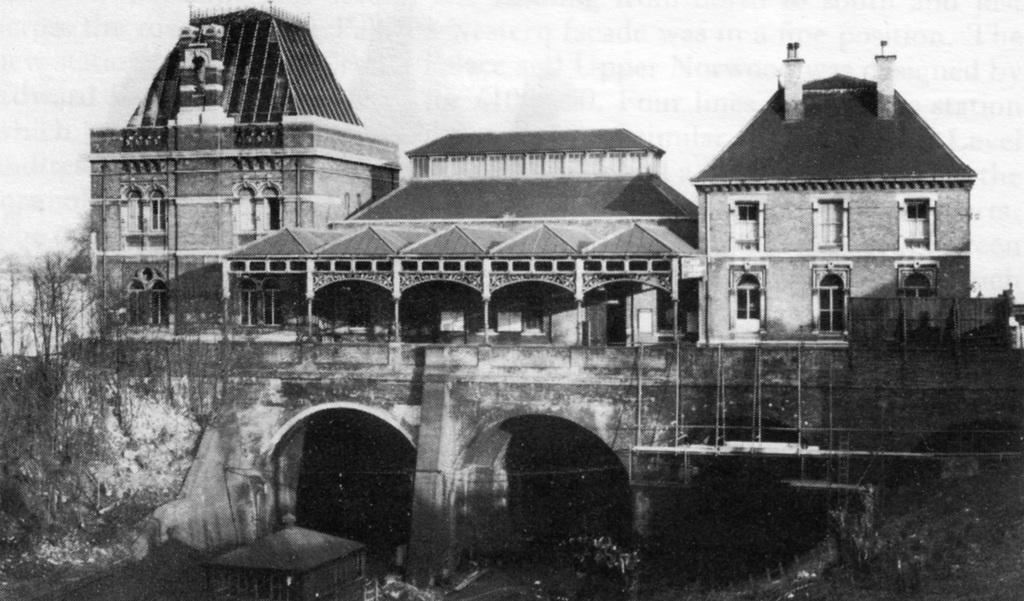What is the main subject in the foreground of the image? There is a building in the foreground of the image. What type of natural elements can be seen in the image? There are trees in the image. What is visible at the top of the image? The sky is visible at the top of the image. Can you tell me how many beetles are crawling on the building in the image? There are no beetles visible on the building in the image. What type of error can be seen in the image? There is no error present in the image. 